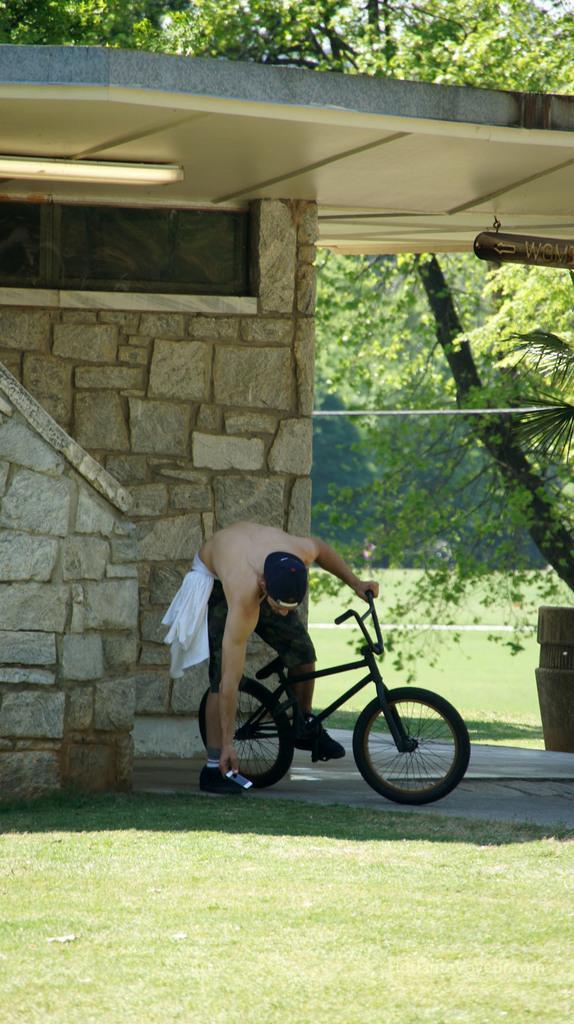Could you give a brief overview of what you see in this image? This is outside of a building. There is ground full of grass. A man is standing. He is bent. He is picking something from the ground. He is holding a bicycle. He is wearing shorts and cap. There is a tree beside the building. We can see many trees in the background. 